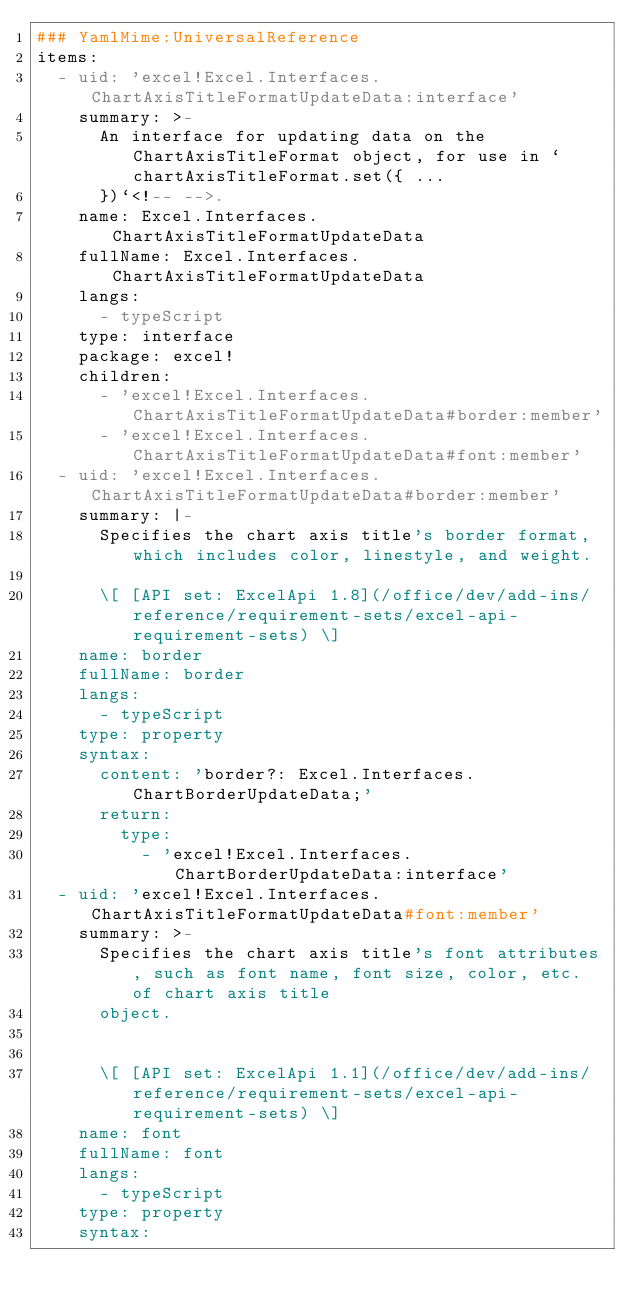Convert code to text. <code><loc_0><loc_0><loc_500><loc_500><_YAML_>### YamlMime:UniversalReference
items:
  - uid: 'excel!Excel.Interfaces.ChartAxisTitleFormatUpdateData:interface'
    summary: >-
      An interface for updating data on the ChartAxisTitleFormat object, for use in `chartAxisTitleFormat.set({ ...
      })`<!-- -->.
    name: Excel.Interfaces.ChartAxisTitleFormatUpdateData
    fullName: Excel.Interfaces.ChartAxisTitleFormatUpdateData
    langs:
      - typeScript
    type: interface
    package: excel!
    children:
      - 'excel!Excel.Interfaces.ChartAxisTitleFormatUpdateData#border:member'
      - 'excel!Excel.Interfaces.ChartAxisTitleFormatUpdateData#font:member'
  - uid: 'excel!Excel.Interfaces.ChartAxisTitleFormatUpdateData#border:member'
    summary: |-
      Specifies the chart axis title's border format, which includes color, linestyle, and weight.

      \[ [API set: ExcelApi 1.8](/office/dev/add-ins/reference/requirement-sets/excel-api-requirement-sets) \]
    name: border
    fullName: border
    langs:
      - typeScript
    type: property
    syntax:
      content: 'border?: Excel.Interfaces.ChartBorderUpdateData;'
      return:
        type:
          - 'excel!Excel.Interfaces.ChartBorderUpdateData:interface'
  - uid: 'excel!Excel.Interfaces.ChartAxisTitleFormatUpdateData#font:member'
    summary: >-
      Specifies the chart axis title's font attributes, such as font name, font size, color, etc. of chart axis title
      object.


      \[ [API set: ExcelApi 1.1](/office/dev/add-ins/reference/requirement-sets/excel-api-requirement-sets) \]
    name: font
    fullName: font
    langs:
      - typeScript
    type: property
    syntax:</code> 